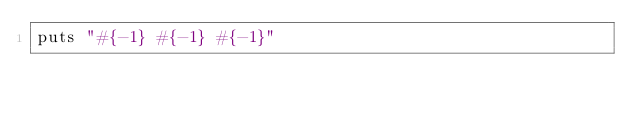<code> <loc_0><loc_0><loc_500><loc_500><_Ruby_>puts "#{-1} #{-1} #{-1}"</code> 